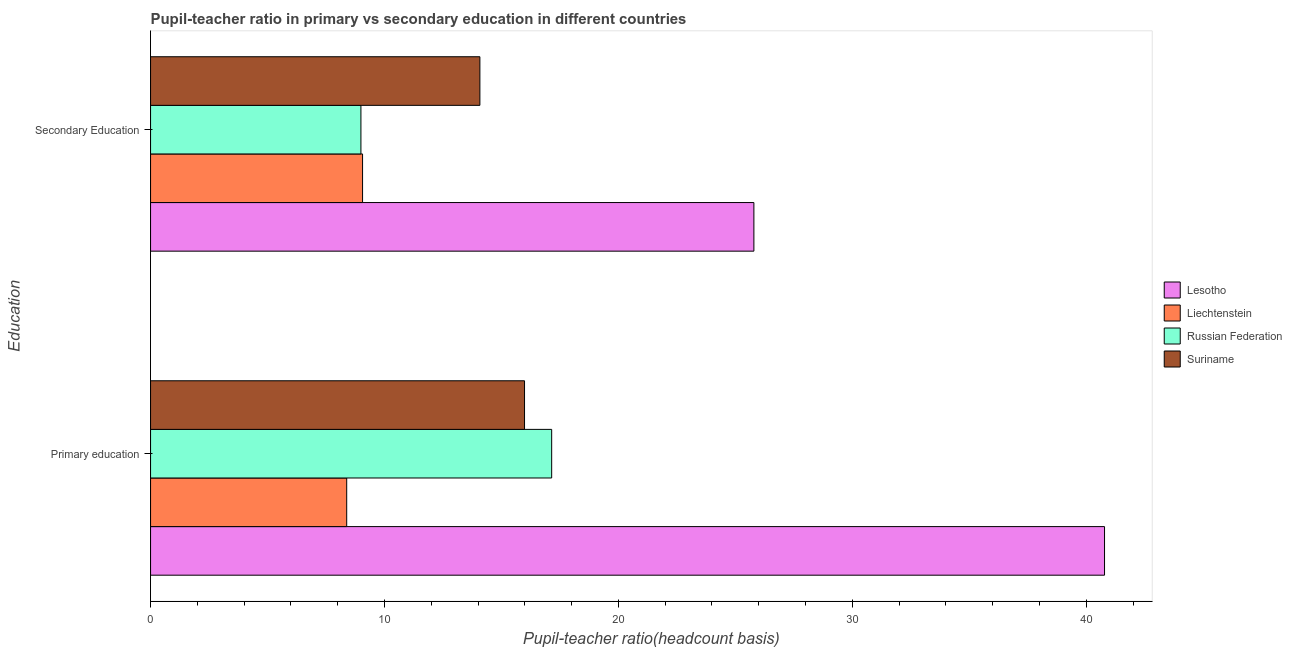How many different coloured bars are there?
Your answer should be compact. 4. How many groups of bars are there?
Your answer should be compact. 2. How many bars are there on the 1st tick from the bottom?
Give a very brief answer. 4. What is the pupil-teacher ratio in primary education in Russian Federation?
Your answer should be very brief. 17.15. Across all countries, what is the maximum pupil teacher ratio on secondary education?
Your answer should be very brief. 25.79. Across all countries, what is the minimum pupil teacher ratio on secondary education?
Ensure brevity in your answer.  8.99. In which country was the pupil teacher ratio on secondary education maximum?
Your answer should be very brief. Lesotho. In which country was the pupil teacher ratio on secondary education minimum?
Your answer should be very brief. Russian Federation. What is the total pupil-teacher ratio in primary education in the graph?
Provide a short and direct response. 82.3. What is the difference between the pupil teacher ratio on secondary education in Russian Federation and that in Suriname?
Provide a short and direct response. -5.09. What is the difference between the pupil-teacher ratio in primary education in Liechtenstein and the pupil teacher ratio on secondary education in Suriname?
Your response must be concise. -5.69. What is the average pupil-teacher ratio in primary education per country?
Offer a very short reply. 20.57. What is the difference between the pupil-teacher ratio in primary education and pupil teacher ratio on secondary education in Liechtenstein?
Offer a terse response. -0.68. What is the ratio of the pupil teacher ratio on secondary education in Liechtenstein to that in Lesotho?
Make the answer very short. 0.35. Is the pupil-teacher ratio in primary education in Russian Federation less than that in Suriname?
Keep it short and to the point. No. In how many countries, is the pupil teacher ratio on secondary education greater than the average pupil teacher ratio on secondary education taken over all countries?
Ensure brevity in your answer.  1. What does the 2nd bar from the top in Primary education represents?
Keep it short and to the point. Russian Federation. What does the 2nd bar from the bottom in Primary education represents?
Offer a very short reply. Liechtenstein. How many bars are there?
Your response must be concise. 8. How many countries are there in the graph?
Your answer should be compact. 4. Are the values on the major ticks of X-axis written in scientific E-notation?
Your response must be concise. No. Where does the legend appear in the graph?
Keep it short and to the point. Center right. How are the legend labels stacked?
Make the answer very short. Vertical. What is the title of the graph?
Keep it short and to the point. Pupil-teacher ratio in primary vs secondary education in different countries. What is the label or title of the X-axis?
Offer a terse response. Pupil-teacher ratio(headcount basis). What is the label or title of the Y-axis?
Make the answer very short. Education. What is the Pupil-teacher ratio(headcount basis) of Lesotho in Primary education?
Offer a very short reply. 40.78. What is the Pupil-teacher ratio(headcount basis) of Liechtenstein in Primary education?
Ensure brevity in your answer.  8.38. What is the Pupil-teacher ratio(headcount basis) in Russian Federation in Primary education?
Ensure brevity in your answer.  17.15. What is the Pupil-teacher ratio(headcount basis) in Suriname in Primary education?
Ensure brevity in your answer.  15.99. What is the Pupil-teacher ratio(headcount basis) of Lesotho in Secondary Education?
Your answer should be very brief. 25.79. What is the Pupil-teacher ratio(headcount basis) of Liechtenstein in Secondary Education?
Offer a terse response. 9.06. What is the Pupil-teacher ratio(headcount basis) in Russian Federation in Secondary Education?
Keep it short and to the point. 8.99. What is the Pupil-teacher ratio(headcount basis) of Suriname in Secondary Education?
Ensure brevity in your answer.  14.08. Across all Education, what is the maximum Pupil-teacher ratio(headcount basis) of Lesotho?
Provide a short and direct response. 40.78. Across all Education, what is the maximum Pupil-teacher ratio(headcount basis) of Liechtenstein?
Your answer should be very brief. 9.06. Across all Education, what is the maximum Pupil-teacher ratio(headcount basis) of Russian Federation?
Offer a very short reply. 17.15. Across all Education, what is the maximum Pupil-teacher ratio(headcount basis) of Suriname?
Ensure brevity in your answer.  15.99. Across all Education, what is the minimum Pupil-teacher ratio(headcount basis) of Lesotho?
Provide a succinct answer. 25.79. Across all Education, what is the minimum Pupil-teacher ratio(headcount basis) of Liechtenstein?
Provide a short and direct response. 8.38. Across all Education, what is the minimum Pupil-teacher ratio(headcount basis) of Russian Federation?
Give a very brief answer. 8.99. Across all Education, what is the minimum Pupil-teacher ratio(headcount basis) in Suriname?
Your answer should be compact. 14.08. What is the total Pupil-teacher ratio(headcount basis) of Lesotho in the graph?
Ensure brevity in your answer.  66.57. What is the total Pupil-teacher ratio(headcount basis) of Liechtenstein in the graph?
Give a very brief answer. 17.45. What is the total Pupil-teacher ratio(headcount basis) in Russian Federation in the graph?
Offer a very short reply. 26.14. What is the total Pupil-teacher ratio(headcount basis) in Suriname in the graph?
Provide a succinct answer. 30.06. What is the difference between the Pupil-teacher ratio(headcount basis) of Lesotho in Primary education and that in Secondary Education?
Your answer should be very brief. 14.99. What is the difference between the Pupil-teacher ratio(headcount basis) of Liechtenstein in Primary education and that in Secondary Education?
Make the answer very short. -0.68. What is the difference between the Pupil-teacher ratio(headcount basis) of Russian Federation in Primary education and that in Secondary Education?
Offer a very short reply. 8.15. What is the difference between the Pupil-teacher ratio(headcount basis) of Suriname in Primary education and that in Secondary Education?
Your answer should be very brief. 1.91. What is the difference between the Pupil-teacher ratio(headcount basis) in Lesotho in Primary education and the Pupil-teacher ratio(headcount basis) in Liechtenstein in Secondary Education?
Your response must be concise. 31.72. What is the difference between the Pupil-teacher ratio(headcount basis) in Lesotho in Primary education and the Pupil-teacher ratio(headcount basis) in Russian Federation in Secondary Education?
Provide a short and direct response. 31.79. What is the difference between the Pupil-teacher ratio(headcount basis) of Lesotho in Primary education and the Pupil-teacher ratio(headcount basis) of Suriname in Secondary Education?
Offer a terse response. 26.7. What is the difference between the Pupil-teacher ratio(headcount basis) in Liechtenstein in Primary education and the Pupil-teacher ratio(headcount basis) in Russian Federation in Secondary Education?
Offer a very short reply. -0.61. What is the difference between the Pupil-teacher ratio(headcount basis) in Liechtenstein in Primary education and the Pupil-teacher ratio(headcount basis) in Suriname in Secondary Education?
Ensure brevity in your answer.  -5.69. What is the difference between the Pupil-teacher ratio(headcount basis) in Russian Federation in Primary education and the Pupil-teacher ratio(headcount basis) in Suriname in Secondary Education?
Give a very brief answer. 3.07. What is the average Pupil-teacher ratio(headcount basis) in Lesotho per Education?
Keep it short and to the point. 33.29. What is the average Pupil-teacher ratio(headcount basis) in Liechtenstein per Education?
Make the answer very short. 8.72. What is the average Pupil-teacher ratio(headcount basis) of Russian Federation per Education?
Offer a terse response. 13.07. What is the average Pupil-teacher ratio(headcount basis) in Suriname per Education?
Provide a short and direct response. 15.03. What is the difference between the Pupil-teacher ratio(headcount basis) in Lesotho and Pupil-teacher ratio(headcount basis) in Liechtenstein in Primary education?
Offer a very short reply. 32.4. What is the difference between the Pupil-teacher ratio(headcount basis) in Lesotho and Pupil-teacher ratio(headcount basis) in Russian Federation in Primary education?
Make the answer very short. 23.63. What is the difference between the Pupil-teacher ratio(headcount basis) of Lesotho and Pupil-teacher ratio(headcount basis) of Suriname in Primary education?
Offer a very short reply. 24.79. What is the difference between the Pupil-teacher ratio(headcount basis) in Liechtenstein and Pupil-teacher ratio(headcount basis) in Russian Federation in Primary education?
Ensure brevity in your answer.  -8.76. What is the difference between the Pupil-teacher ratio(headcount basis) in Liechtenstein and Pupil-teacher ratio(headcount basis) in Suriname in Primary education?
Ensure brevity in your answer.  -7.6. What is the difference between the Pupil-teacher ratio(headcount basis) of Russian Federation and Pupil-teacher ratio(headcount basis) of Suriname in Primary education?
Your answer should be compact. 1.16. What is the difference between the Pupil-teacher ratio(headcount basis) of Lesotho and Pupil-teacher ratio(headcount basis) of Liechtenstein in Secondary Education?
Provide a short and direct response. 16.73. What is the difference between the Pupil-teacher ratio(headcount basis) in Lesotho and Pupil-teacher ratio(headcount basis) in Russian Federation in Secondary Education?
Ensure brevity in your answer.  16.8. What is the difference between the Pupil-teacher ratio(headcount basis) of Lesotho and Pupil-teacher ratio(headcount basis) of Suriname in Secondary Education?
Provide a succinct answer. 11.71. What is the difference between the Pupil-teacher ratio(headcount basis) of Liechtenstein and Pupil-teacher ratio(headcount basis) of Russian Federation in Secondary Education?
Your answer should be very brief. 0.07. What is the difference between the Pupil-teacher ratio(headcount basis) in Liechtenstein and Pupil-teacher ratio(headcount basis) in Suriname in Secondary Education?
Offer a very short reply. -5.02. What is the difference between the Pupil-teacher ratio(headcount basis) in Russian Federation and Pupil-teacher ratio(headcount basis) in Suriname in Secondary Education?
Your answer should be very brief. -5.09. What is the ratio of the Pupil-teacher ratio(headcount basis) in Lesotho in Primary education to that in Secondary Education?
Make the answer very short. 1.58. What is the ratio of the Pupil-teacher ratio(headcount basis) of Liechtenstein in Primary education to that in Secondary Education?
Your response must be concise. 0.93. What is the ratio of the Pupil-teacher ratio(headcount basis) of Russian Federation in Primary education to that in Secondary Education?
Offer a very short reply. 1.91. What is the ratio of the Pupil-teacher ratio(headcount basis) in Suriname in Primary education to that in Secondary Education?
Offer a terse response. 1.14. What is the difference between the highest and the second highest Pupil-teacher ratio(headcount basis) of Lesotho?
Give a very brief answer. 14.99. What is the difference between the highest and the second highest Pupil-teacher ratio(headcount basis) in Liechtenstein?
Offer a very short reply. 0.68. What is the difference between the highest and the second highest Pupil-teacher ratio(headcount basis) in Russian Federation?
Give a very brief answer. 8.15. What is the difference between the highest and the second highest Pupil-teacher ratio(headcount basis) in Suriname?
Provide a succinct answer. 1.91. What is the difference between the highest and the lowest Pupil-teacher ratio(headcount basis) in Lesotho?
Give a very brief answer. 14.99. What is the difference between the highest and the lowest Pupil-teacher ratio(headcount basis) of Liechtenstein?
Your answer should be compact. 0.68. What is the difference between the highest and the lowest Pupil-teacher ratio(headcount basis) in Russian Federation?
Give a very brief answer. 8.15. What is the difference between the highest and the lowest Pupil-teacher ratio(headcount basis) of Suriname?
Give a very brief answer. 1.91. 